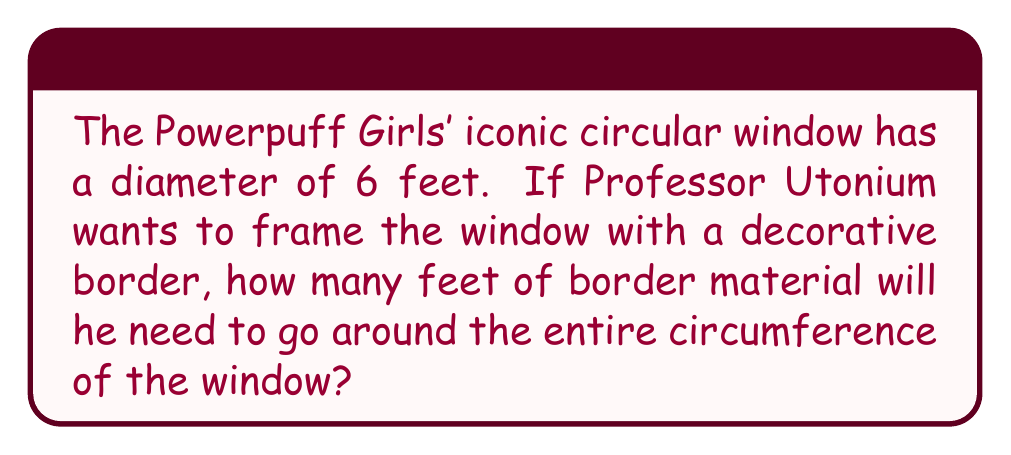Show me your answer to this math problem. Let's solve this step-by-step:

1) First, we need to recall the formula for the circumference of a circle:
   $$C = \pi d$$
   where $C$ is the circumference and $d$ is the diameter.

2) We're given that the diameter is 6 feet. Let's substitute this into our formula:
   $$C = \pi \cdot 6$$

3) Now, let's calculate:
   $$C = 6\pi \approx 18.85 \text{ feet}$$

4) We can leave our answer in terms of $\pi$ for an exact solution, or round to two decimal places for a practical measurement.

[asy]
unitsize(20);
draw(circle((0,0),3), rgb(0,0,1));
draw((-3,0)--(3,0), dashed);
label("6 feet", (0,-3.5), S);
label("Powerpuff Girls' Window", (0,3.5), N);
[/asy]
Answer: $6\pi$ feet or approximately 18.85 feet 